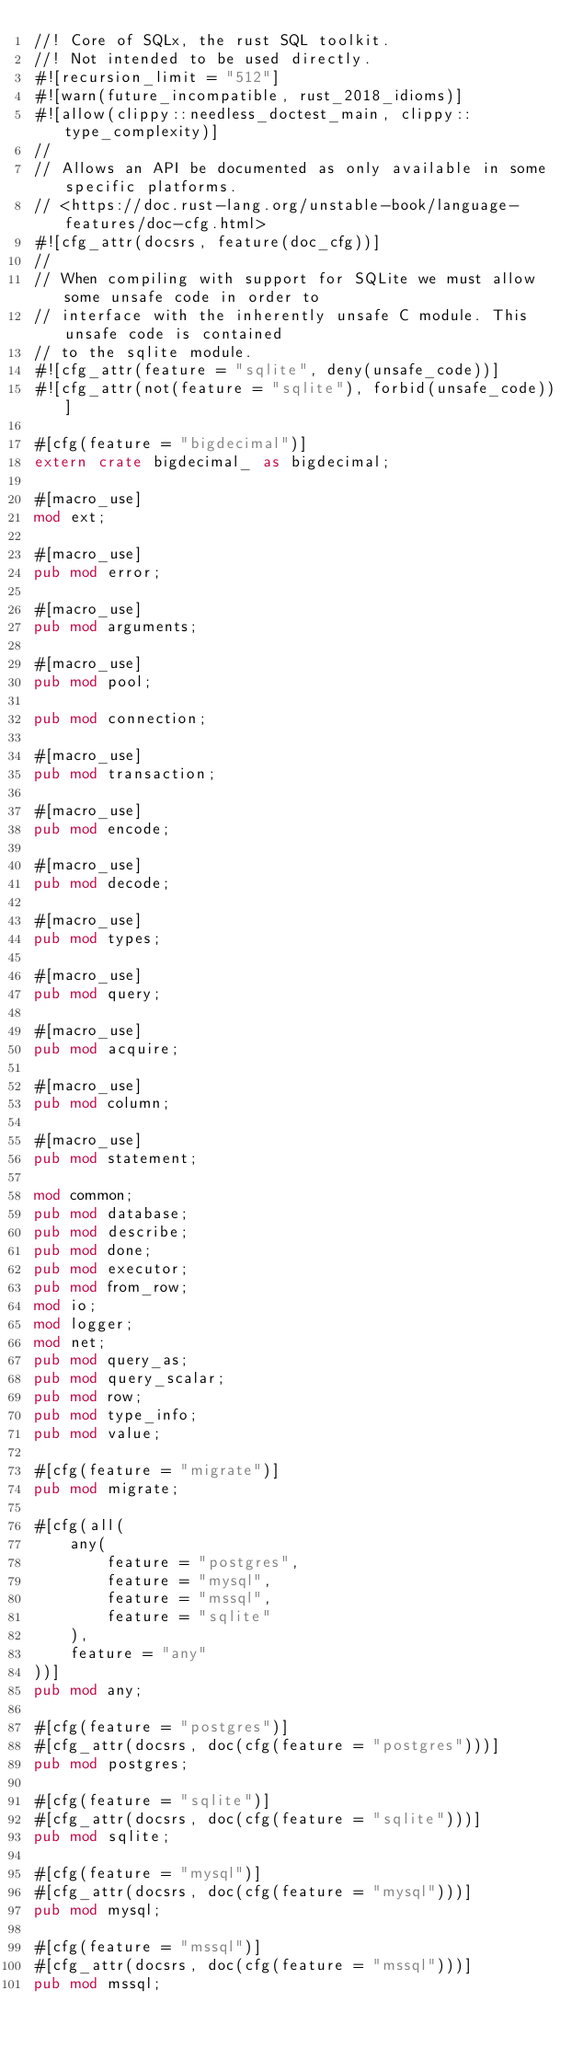Convert code to text. <code><loc_0><loc_0><loc_500><loc_500><_Rust_>//! Core of SQLx, the rust SQL toolkit.
//! Not intended to be used directly.
#![recursion_limit = "512"]
#![warn(future_incompatible, rust_2018_idioms)]
#![allow(clippy::needless_doctest_main, clippy::type_complexity)]
//
// Allows an API be documented as only available in some specific platforms.
// <https://doc.rust-lang.org/unstable-book/language-features/doc-cfg.html>
#![cfg_attr(docsrs, feature(doc_cfg))]
//
// When compiling with support for SQLite we must allow some unsafe code in order to
// interface with the inherently unsafe C module. This unsafe code is contained
// to the sqlite module.
#![cfg_attr(feature = "sqlite", deny(unsafe_code))]
#![cfg_attr(not(feature = "sqlite"), forbid(unsafe_code))]

#[cfg(feature = "bigdecimal")]
extern crate bigdecimal_ as bigdecimal;

#[macro_use]
mod ext;

#[macro_use]
pub mod error;

#[macro_use]
pub mod arguments;

#[macro_use]
pub mod pool;

pub mod connection;

#[macro_use]
pub mod transaction;

#[macro_use]
pub mod encode;

#[macro_use]
pub mod decode;

#[macro_use]
pub mod types;

#[macro_use]
pub mod query;

#[macro_use]
pub mod acquire;

#[macro_use]
pub mod column;

#[macro_use]
pub mod statement;

mod common;
pub mod database;
pub mod describe;
pub mod done;
pub mod executor;
pub mod from_row;
mod io;
mod logger;
mod net;
pub mod query_as;
pub mod query_scalar;
pub mod row;
pub mod type_info;
pub mod value;

#[cfg(feature = "migrate")]
pub mod migrate;

#[cfg(all(
    any(
        feature = "postgres",
        feature = "mysql",
        feature = "mssql",
        feature = "sqlite"
    ),
    feature = "any"
))]
pub mod any;

#[cfg(feature = "postgres")]
#[cfg_attr(docsrs, doc(cfg(feature = "postgres")))]
pub mod postgres;

#[cfg(feature = "sqlite")]
#[cfg_attr(docsrs, doc(cfg(feature = "sqlite")))]
pub mod sqlite;

#[cfg(feature = "mysql")]
#[cfg_attr(docsrs, doc(cfg(feature = "mysql")))]
pub mod mysql;

#[cfg(feature = "mssql")]
#[cfg_attr(docsrs, doc(cfg(feature = "mssql")))]
pub mod mssql;
</code> 